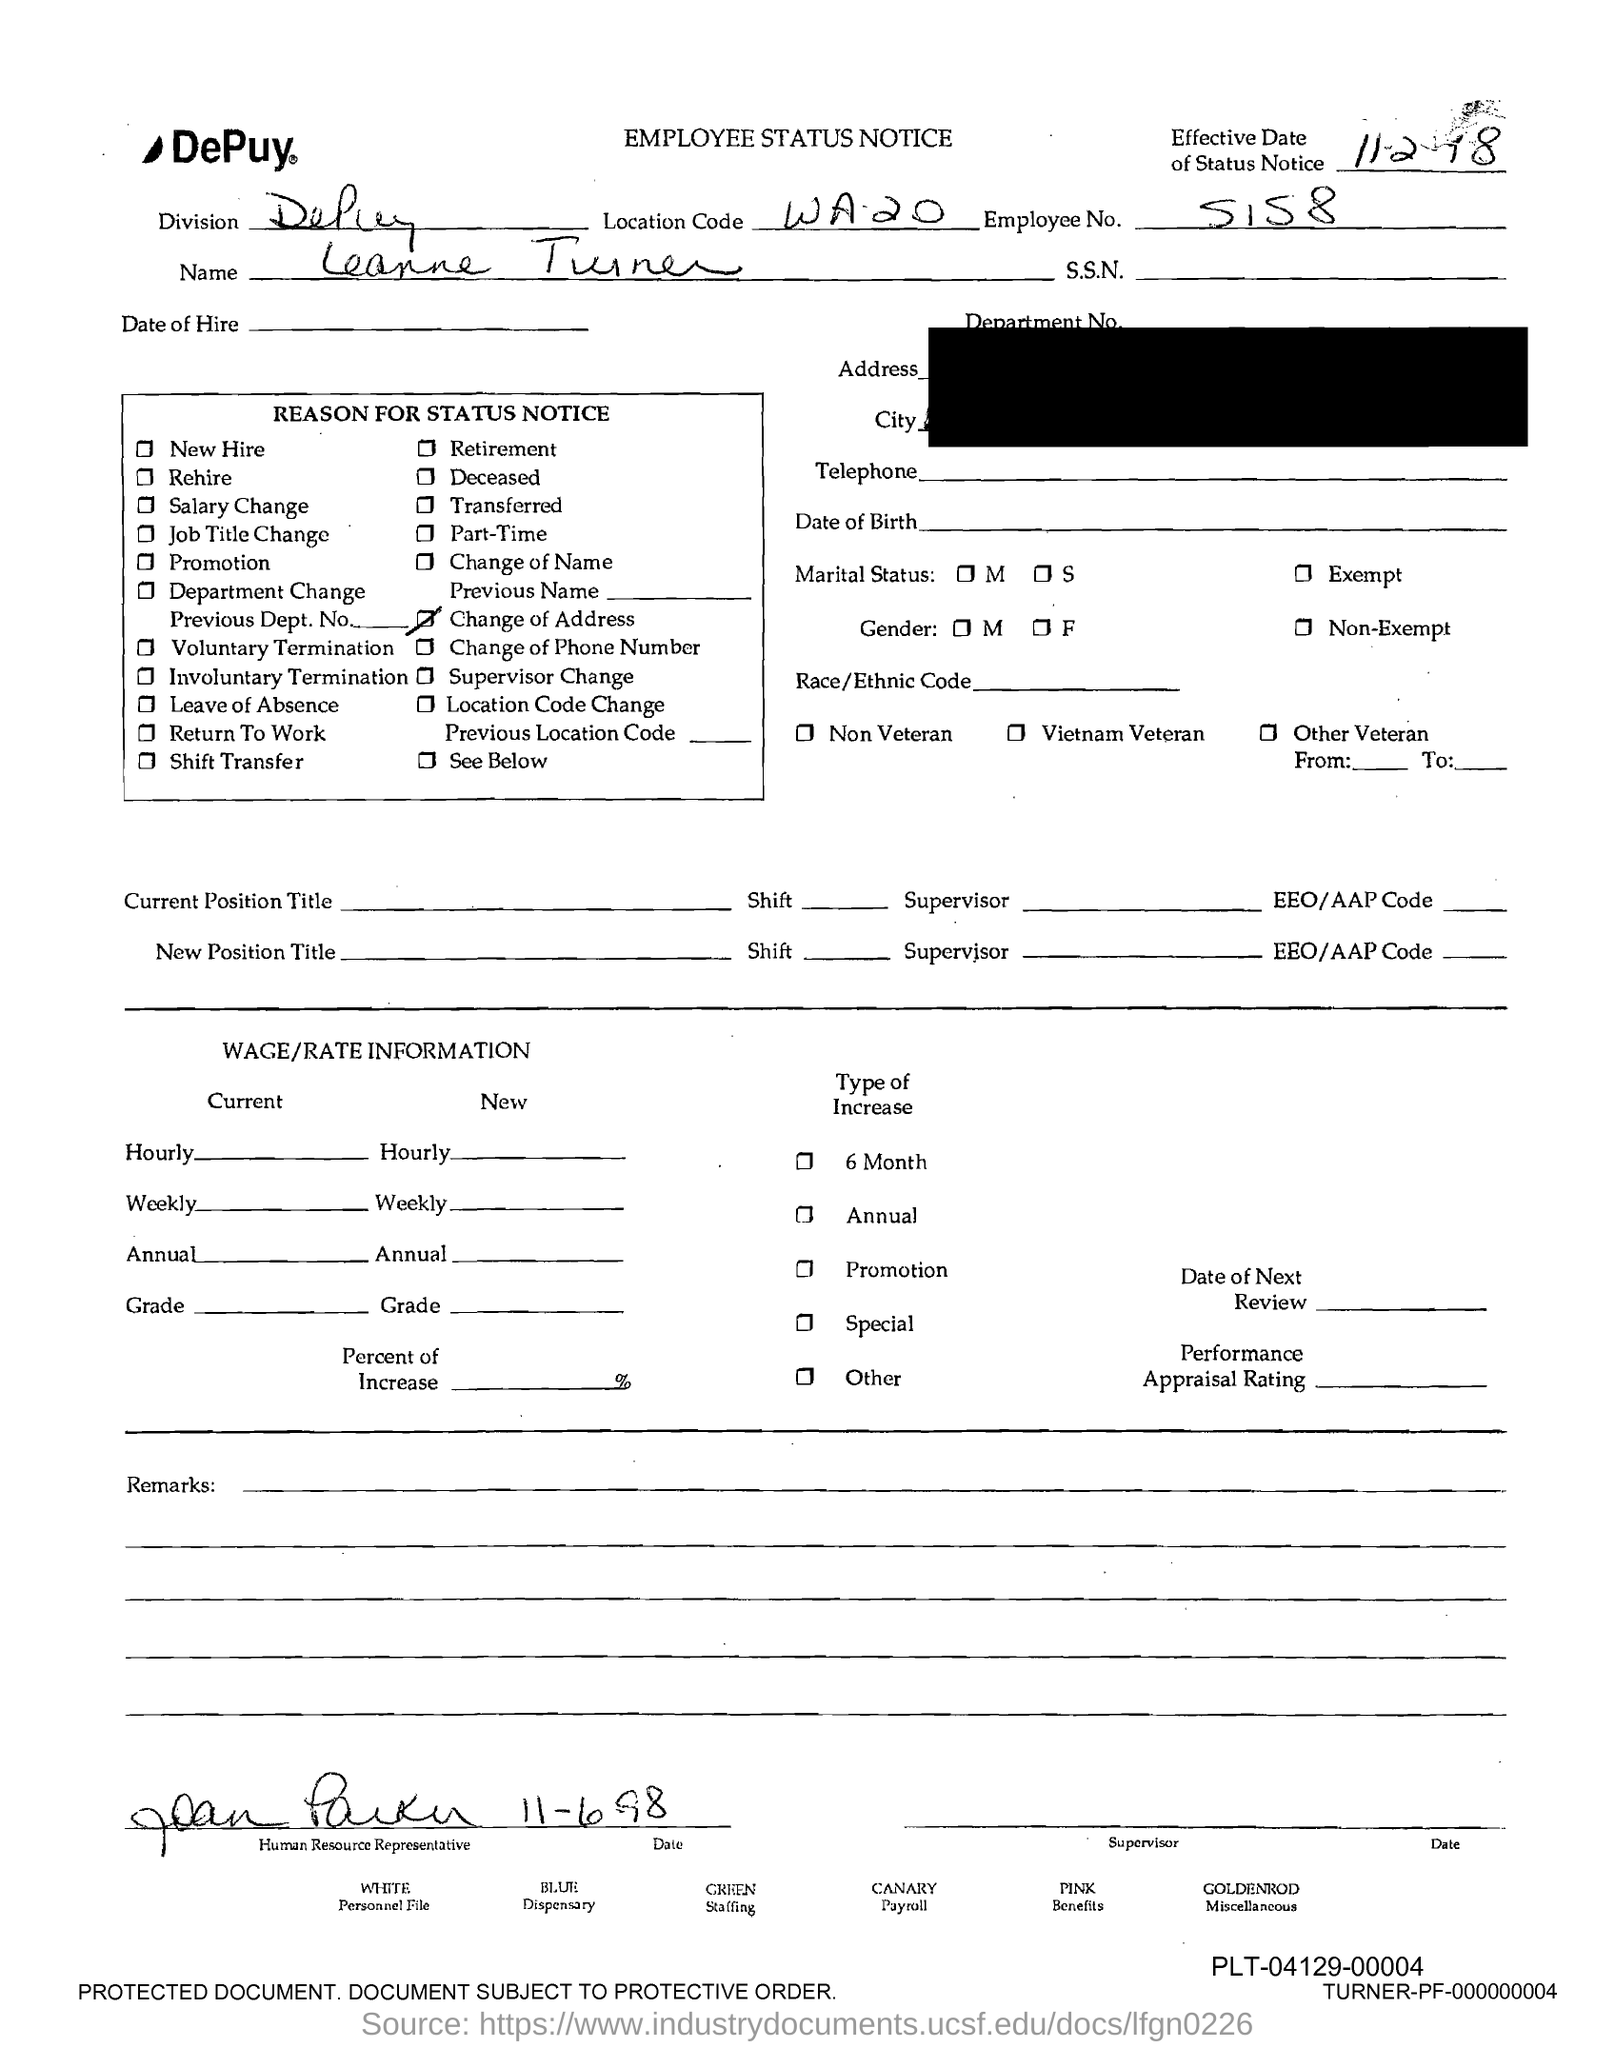What is the employee no?
Offer a very short reply. 5158. What is the location code?
Make the answer very short. WA.20. 